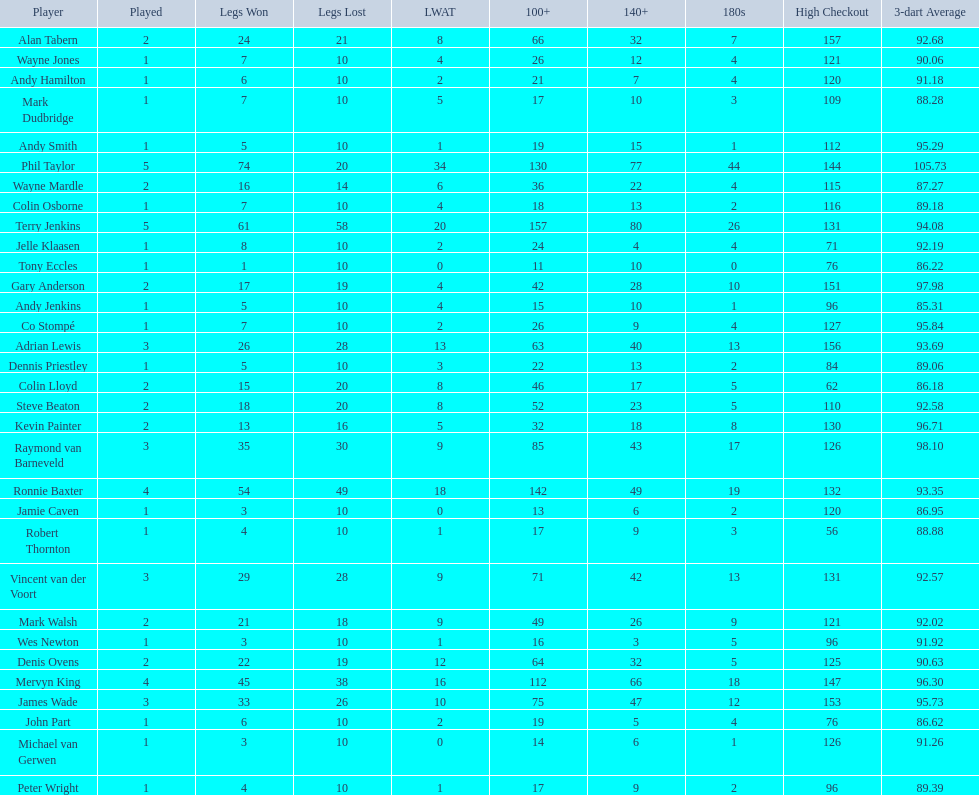How many players in the 2009 world matchplay won at least 30 legs? 6. Give me the full table as a dictionary. {'header': ['Player', 'Played', 'Legs Won', 'Legs Lost', 'LWAT', '100+', '140+', '180s', 'High Checkout', '3-dart Average'], 'rows': [['Alan Tabern', '2', '24', '21', '8', '66', '32', '7', '157', '92.68'], ['Wayne Jones', '1', '7', '10', '4', '26', '12', '4', '121', '90.06'], ['Andy Hamilton', '1', '6', '10', '2', '21', '7', '4', '120', '91.18'], ['Mark Dudbridge', '1', '7', '10', '5', '17', '10', '3', '109', '88.28'], ['Andy Smith', '1', '5', '10', '1', '19', '15', '1', '112', '95.29'], ['Phil Taylor', '5', '74', '20', '34', '130', '77', '44', '144', '105.73'], ['Wayne Mardle', '2', '16', '14', '6', '36', '22', '4', '115', '87.27'], ['Colin Osborne', '1', '7', '10', '4', '18', '13', '2', '116', '89.18'], ['Terry Jenkins', '5', '61', '58', '20', '157', '80', '26', '131', '94.08'], ['Jelle Klaasen', '1', '8', '10', '2', '24', '4', '4', '71', '92.19'], ['Tony Eccles', '1', '1', '10', '0', '11', '10', '0', '76', '86.22'], ['Gary Anderson', '2', '17', '19', '4', '42', '28', '10', '151', '97.98'], ['Andy Jenkins', '1', '5', '10', '4', '15', '10', '1', '96', '85.31'], ['Co Stompé', '1', '7', '10', '2', '26', '9', '4', '127', '95.84'], ['Adrian Lewis', '3', '26', '28', '13', '63', '40', '13', '156', '93.69'], ['Dennis Priestley', '1', '5', '10', '3', '22', '13', '2', '84', '89.06'], ['Colin Lloyd', '2', '15', '20', '8', '46', '17', '5', '62', '86.18'], ['Steve Beaton', '2', '18', '20', '8', '52', '23', '5', '110', '92.58'], ['Kevin Painter', '2', '13', '16', '5', '32', '18', '8', '130', '96.71'], ['Raymond van Barneveld', '3', '35', '30', '9', '85', '43', '17', '126', '98.10'], ['Ronnie Baxter', '4', '54', '49', '18', '142', '49', '19', '132', '93.35'], ['Jamie Caven', '1', '3', '10', '0', '13', '6', '2', '120', '86.95'], ['Robert Thornton', '1', '4', '10', '1', '17', '9', '3', '56', '88.88'], ['Vincent van der Voort', '3', '29', '28', '9', '71', '42', '13', '131', '92.57'], ['Mark Walsh', '2', '21', '18', '9', '49', '26', '9', '121', '92.02'], ['Wes Newton', '1', '3', '10', '1', '16', '3', '5', '96', '91.92'], ['Denis Ovens', '2', '22', '19', '12', '64', '32', '5', '125', '90.63'], ['Mervyn King', '4', '45', '38', '16', '112', '66', '18', '147', '96.30'], ['James Wade', '3', '33', '26', '10', '75', '47', '12', '153', '95.73'], ['John Part', '1', '6', '10', '2', '19', '5', '4', '76', '86.62'], ['Michael van Gerwen', '1', '3', '10', '0', '14', '6', '1', '126', '91.26'], ['Peter Wright', '1', '4', '10', '1', '17', '9', '2', '96', '89.39']]} 